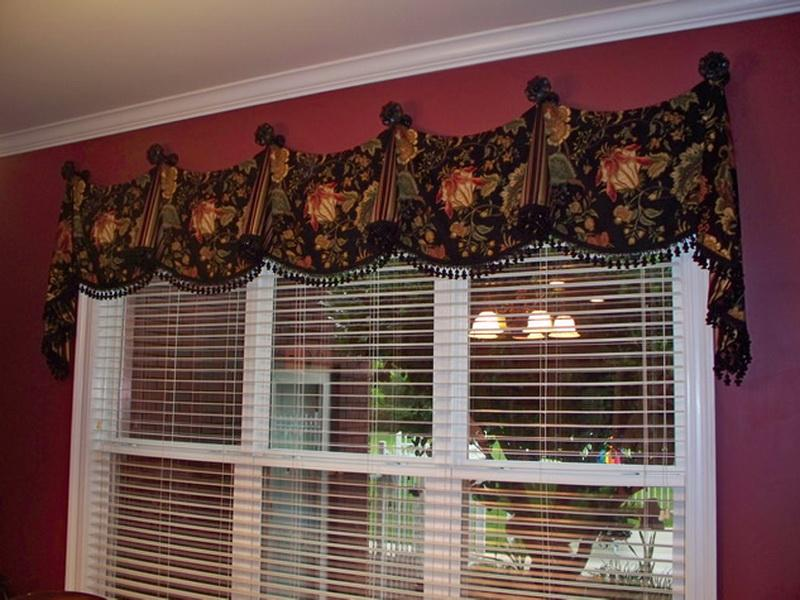How might the color choices in the window treatment and the wall affect the feel of the room? The rich, deep burgundy of the wall, when juxtaposed with the dark floral patterns of the window treatment, creates a mood of warmth and depth. The bold use of color can make the room feel intimate and cozy, while also serving as a backdrop that highlights the elegance of the decor. Such colors tend to absorb light, which could make the space feel smaller but also more inviting and snug, depending on the lighting and complementary accessories used. The choices reflect a preference for an intimate space meant for relaxation or formal socializing. 